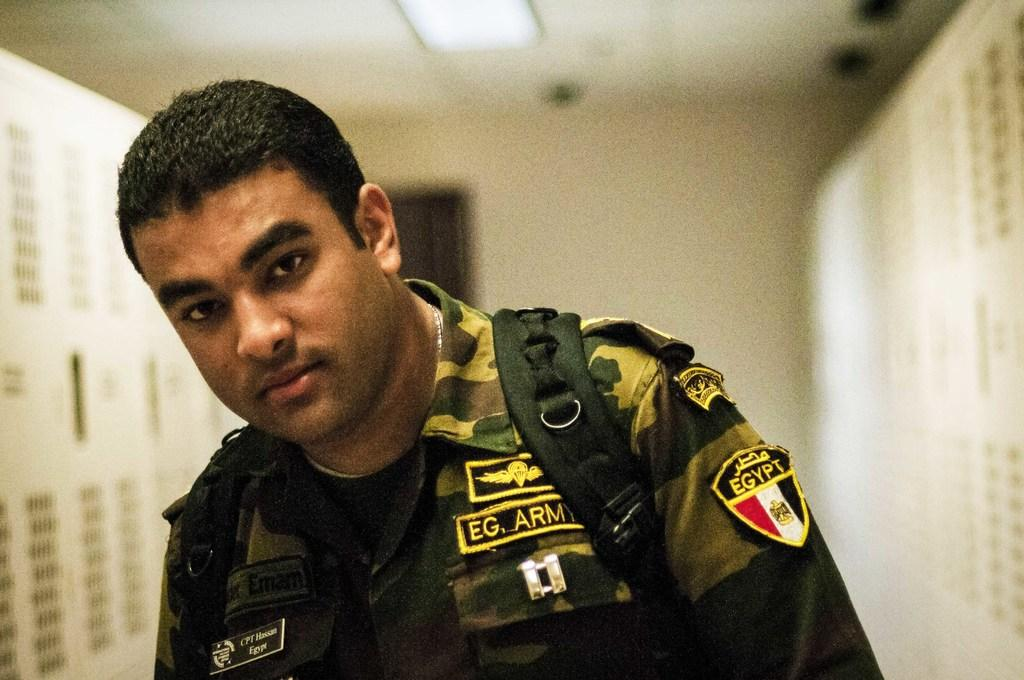Who or what is present in the image? There is a person in the image. What is located above the person in the image? There is a light on top in the image. Can you describe the background of the image? The background of the image is blurry. How many bears can be seen in the image? There are no bears present in the image. What type of bulb is used in the light fixture in the image? The image does not provide enough detail to determine the type of bulb used in the light fixture. Is there a cannon visible in the image? There is no cannon present in the image. 